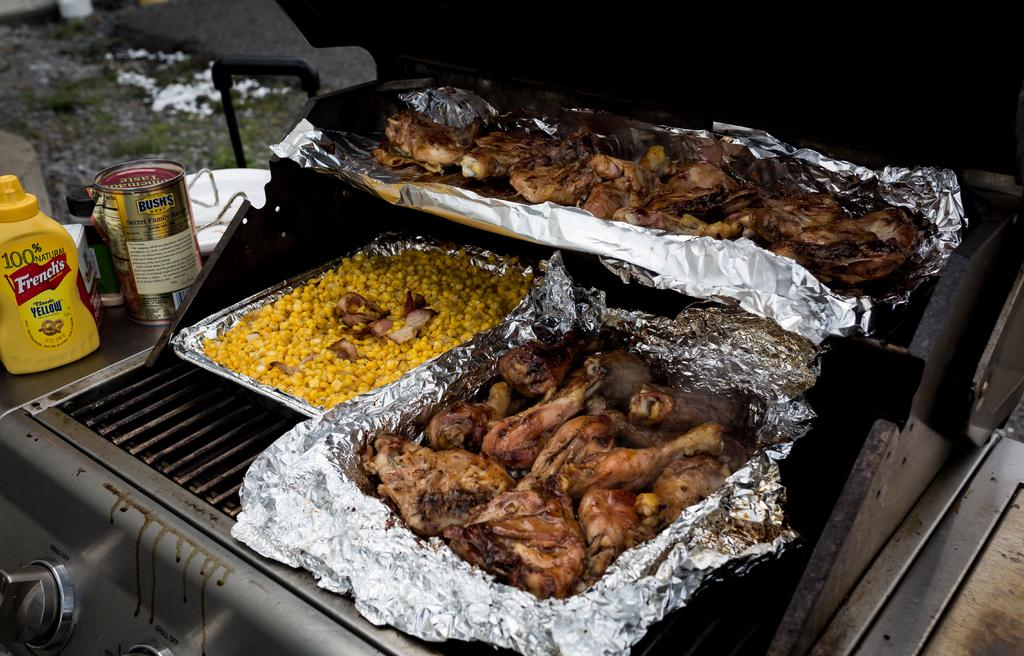<image>
Describe the image concisely. A bottle of French's yellow mustard and Bush's baked beans on a barbecue table. 